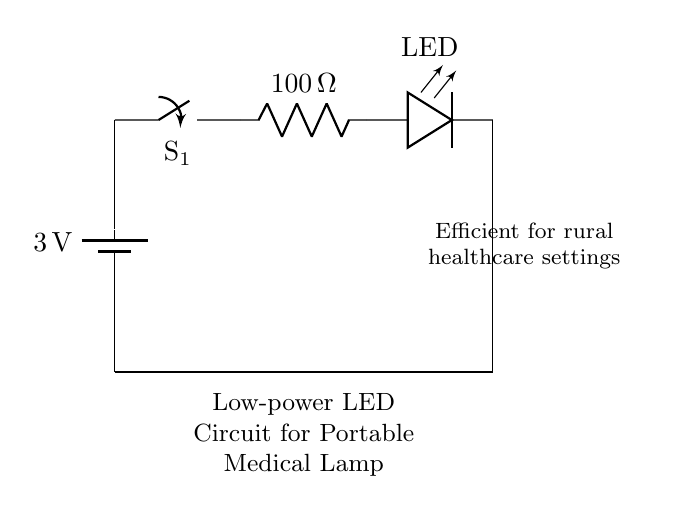What is the voltage of this circuit? The voltage is 3 volts, indicated by the battery in the diagram showing a label of 3V.
Answer: 3 volts What is the purpose of the switch in the circuit? The switch is used to control the flow of electricity; when it is open, the circuit is off, and when it is closed, the circuit is on.
Answer: Control flow What is the value of the current limiting resistor? The current limiting resistor is labeled as 100 ohms in the circuit.
Answer: 100 ohms What type of lamp is used in this circuit? The circuit uses an LED lamp as indicated by the component labeled 'LED'.
Answer: LED How does the circuit ensure safe operation for the LED? The circuit uses a current limiting resistor which reduces the current flowing to the LED, protecting it from damage.
Answer: Current limiting resistor What other component connects back to the battery? The LED connects back to the battery, completing the circuit loop.
Answer: LED What is the application of this circuit in healthcare? This circuit is designed for portable medical examination lamps, providing a low-power, efficient lighting solution in rural healthcare settings.
Answer: Portable medical lamp 